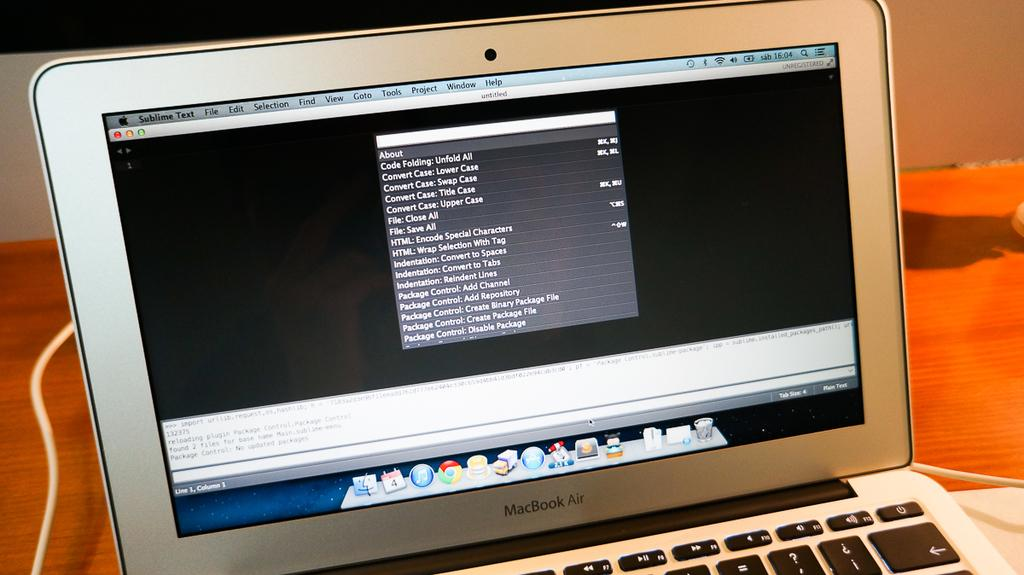Provide a one-sentence caption for the provided image. A macbook sits on a tabletop with a browser open. 